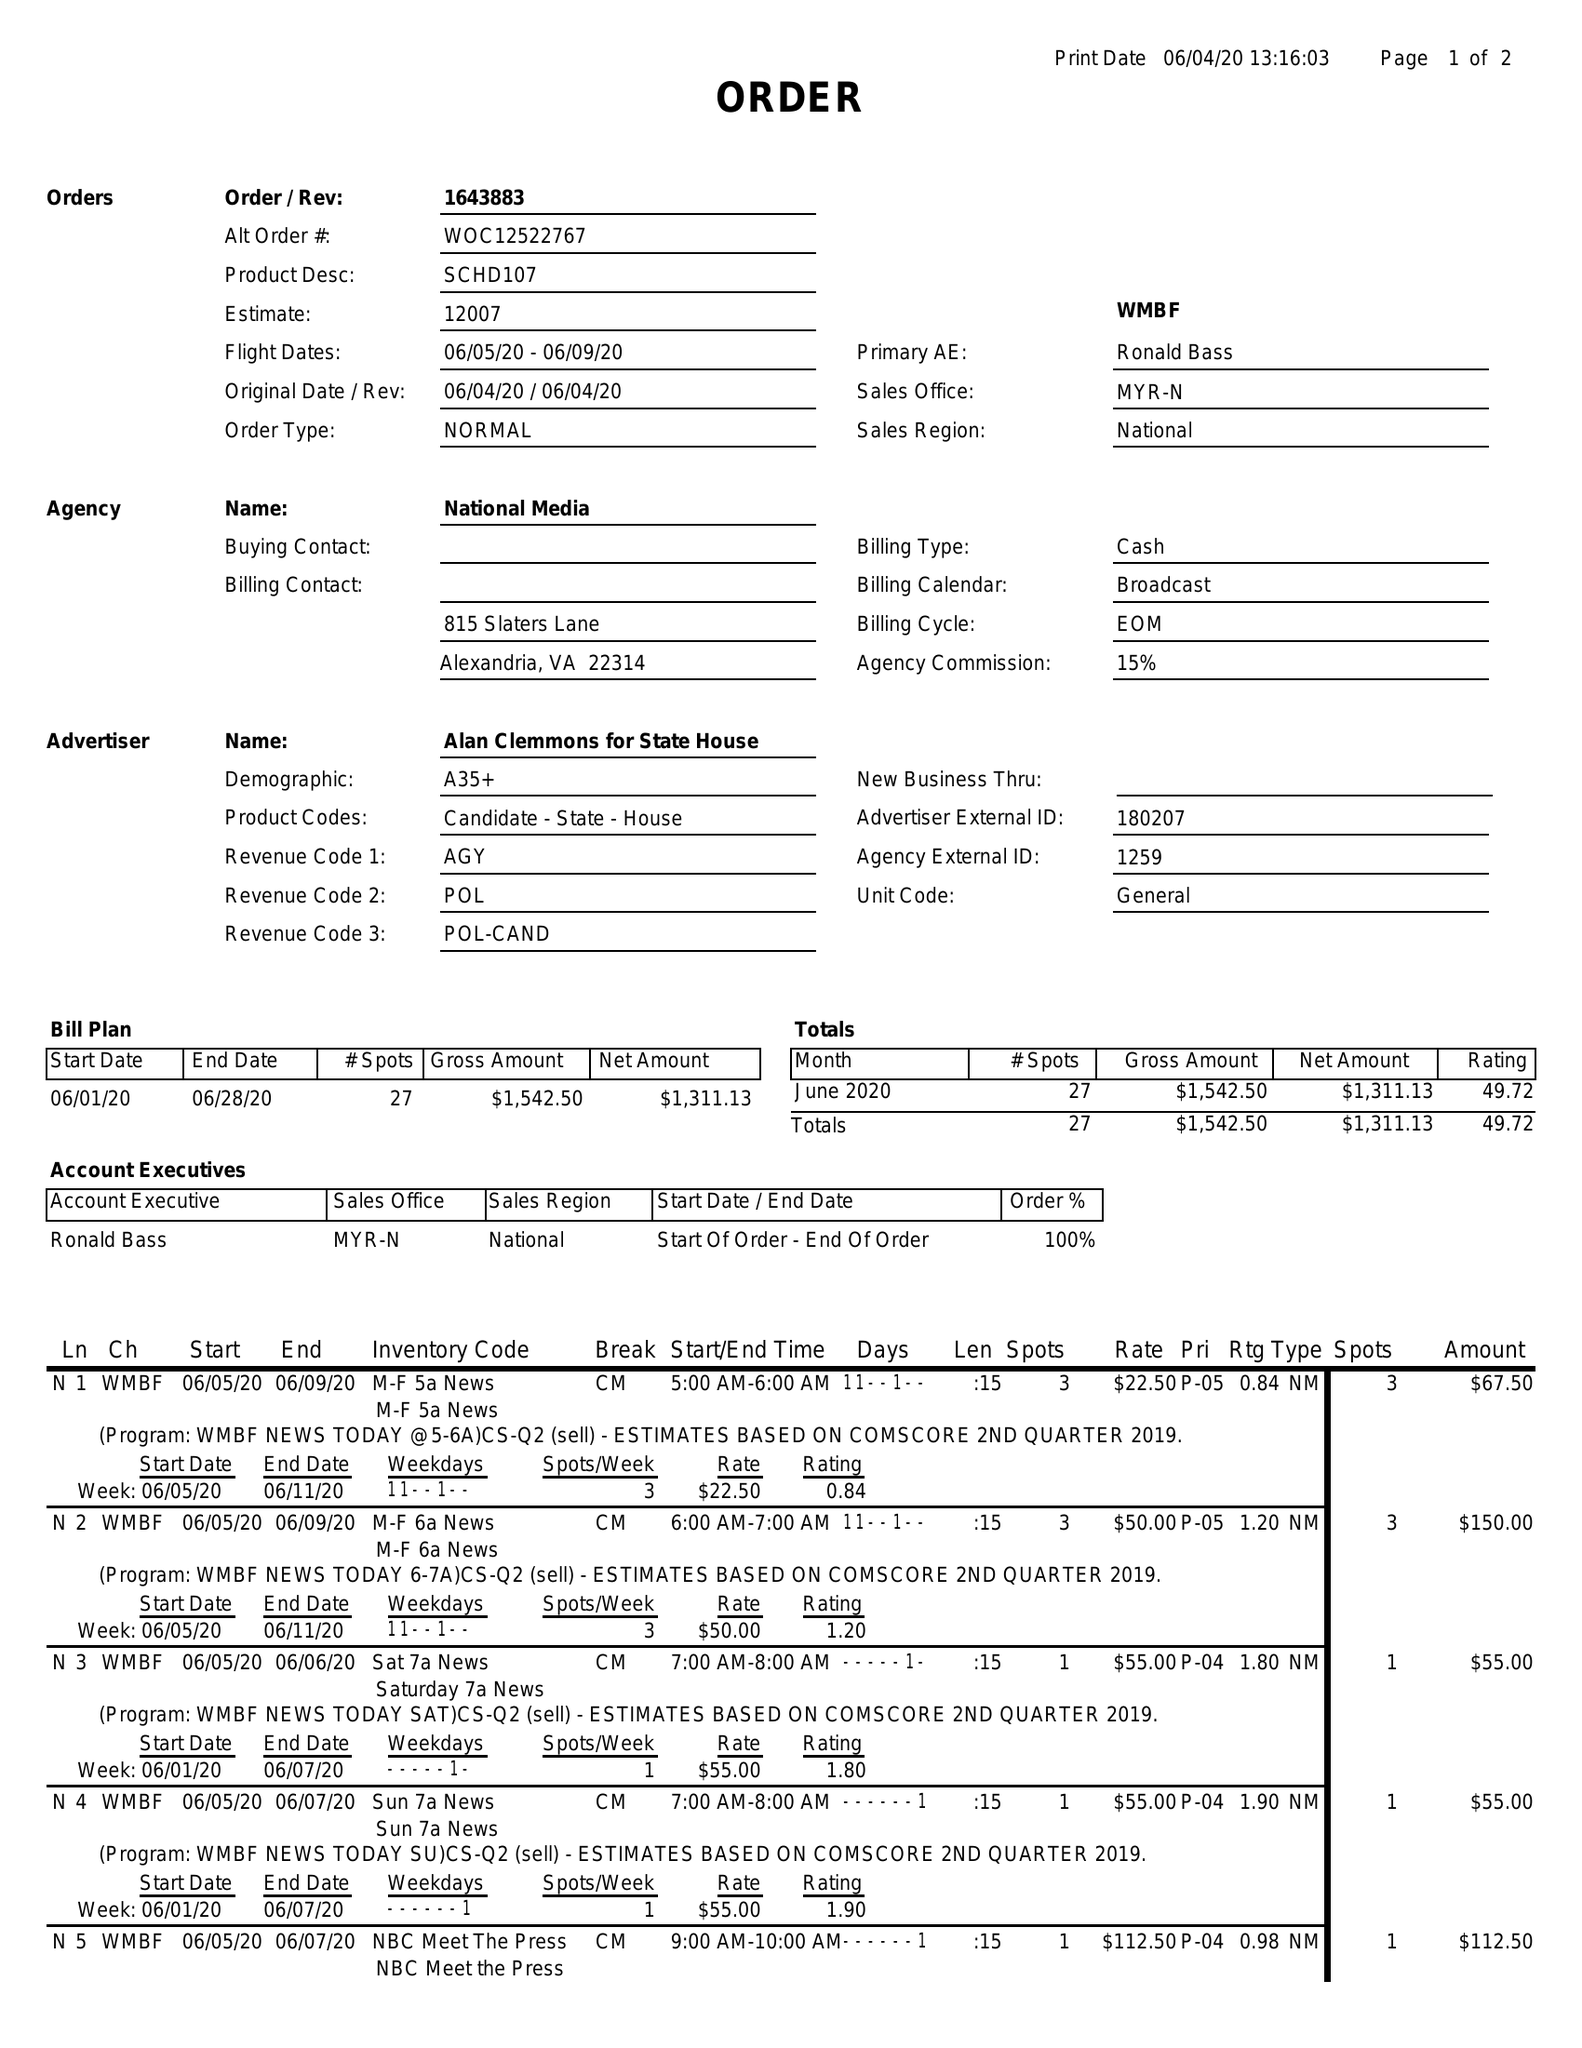What is the value for the advertiser?
Answer the question using a single word or phrase. ALAN CLEMMONS FOR STATE HOUSE 